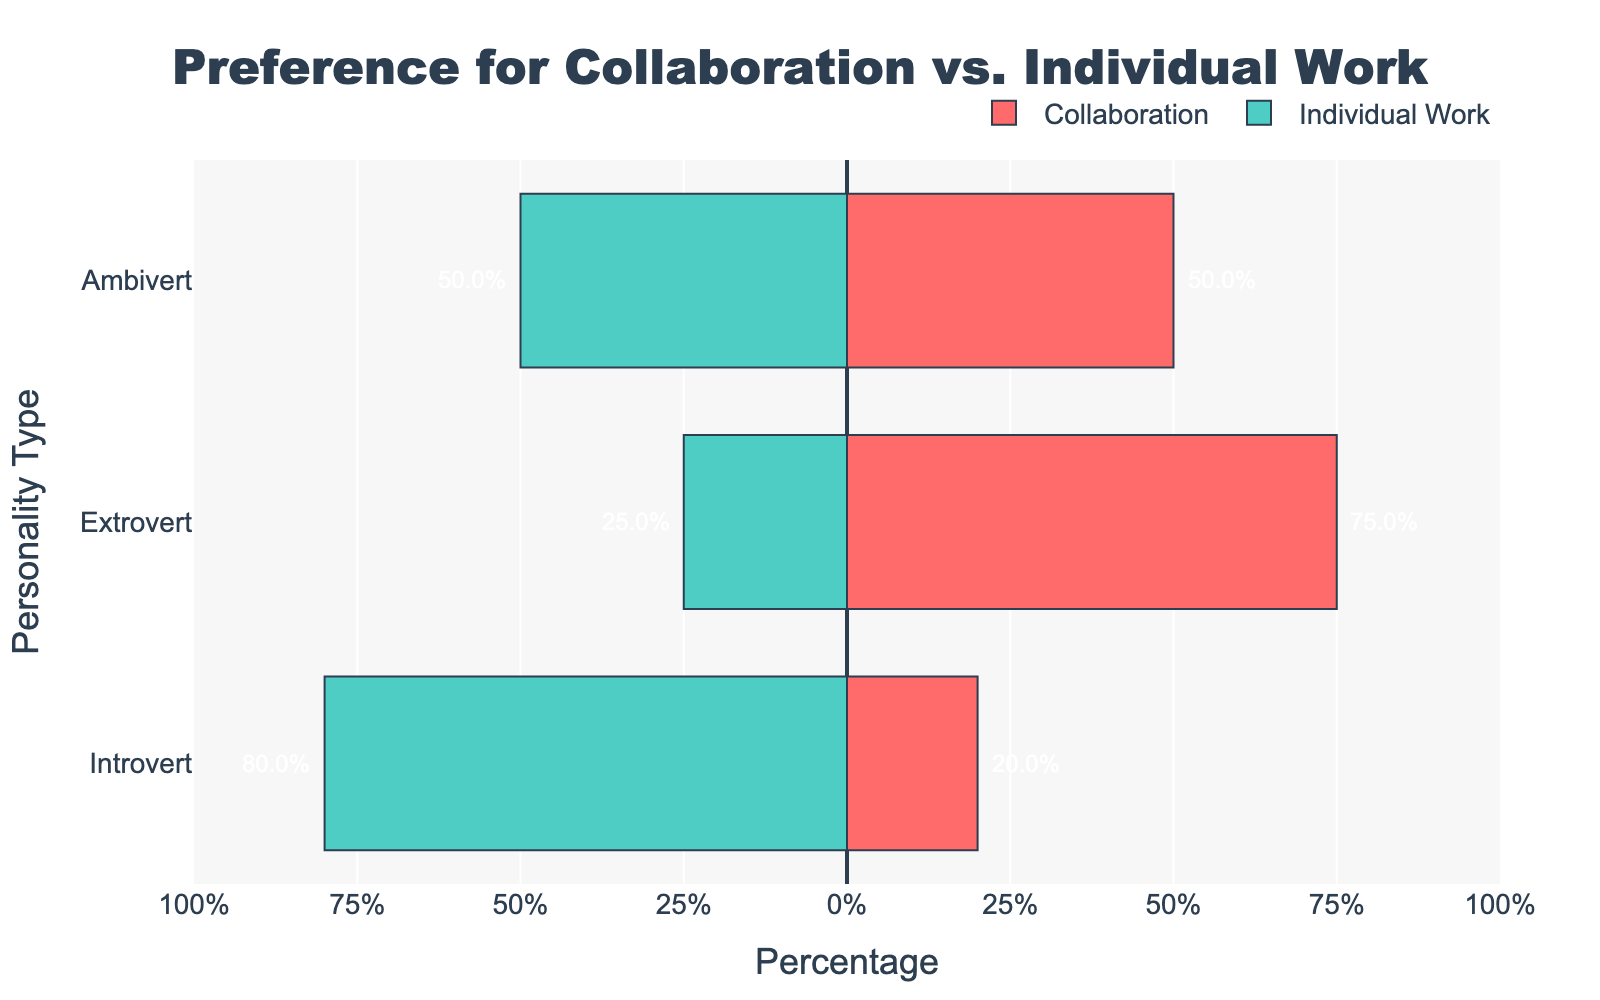What percentage of introverts prefer individual work? Look at the bar corresponding to 'Introvert' under the 'Individual Work' category. The length of the bar is labeled, showing 80%.
Answer: 80% What is the difference in preference for collaboration between extroverts and ambiverts? Find the percentages for extroverts and ambiverts for the 'Collaboration' category, which are 75% and 50%, respectively. Calculate the difference: 75% - 50% = 25%.
Answer: 25% Which personality type has the highest preference for individual work? Compare the lengths of the 'Individual Work' bars across all personality types. The longest is for 'Introvert' at 80%.
Answer: Introvert What is the sum of the preferences for individual work across all personality types? Add the lengths of all 'Individual Work' bars: 80% (Introvert) + 25% (Extrovert) + 50% (Ambivert). The sum is 80 + 25 + 50 = 155%.
Answer: 155% Does any personality type show an equal preference for both collaboration and individual work? Look at the bars where the percentages for 'Collaboration' and 'Individual Work' are the same. Ambivert shows 50% for each.
Answer: Ambivert In terms of collaboration, which personality type shows the least preference? Compare the lengths of the 'Collaboration' bars for all personality types. 'Introvert' shows the lowest at 20%.
Answer: Introvert What is the average preference percentage for collaboration among all personality types? Add the percentages for 'Collaboration' for all personality types and divide by the number of types: (20% + 75% + 50%) / 3 = 145% / 3 ≈ 48.33%.
Answer: 48.33% How much more do extroverts prefer collaboration over individual work? Look at the 'Collaboration' and 'Individual Work' percentages for extroverts. Calculate the difference: 75% - 25% = 50%.
Answer: 50% Which category (collaboration or individual work) generally has higher percentages across all personality types? Assess the overall bar lengths for 'Collaboration' and 'Individual Work'. Summing both gives individual work: 80% + 25% + 50% = 155%, and collaboration: 20% + 75% + 50% = 145%. Individual work is higher.
Answer: Individual Work By what percentage do introverts prefer individual work over collaboration? Compare the 'Individual Work' and 'Collaboration' percentages for introverts. Calculate the difference: 80% - 20% = 60%.
Answer: 60% 